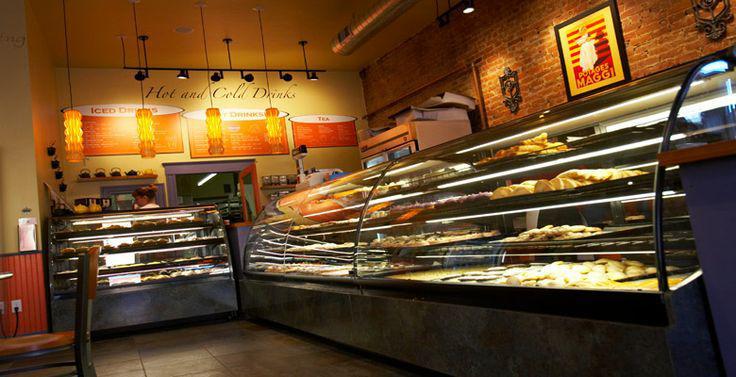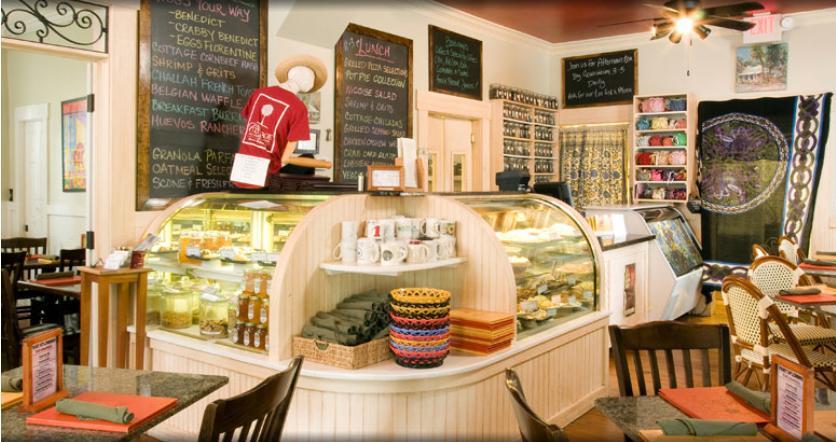The first image is the image on the left, the second image is the image on the right. Assess this claim about the two images: "One bakery has a glassed display that curves around a corner.". Correct or not? Answer yes or no. Yes. 